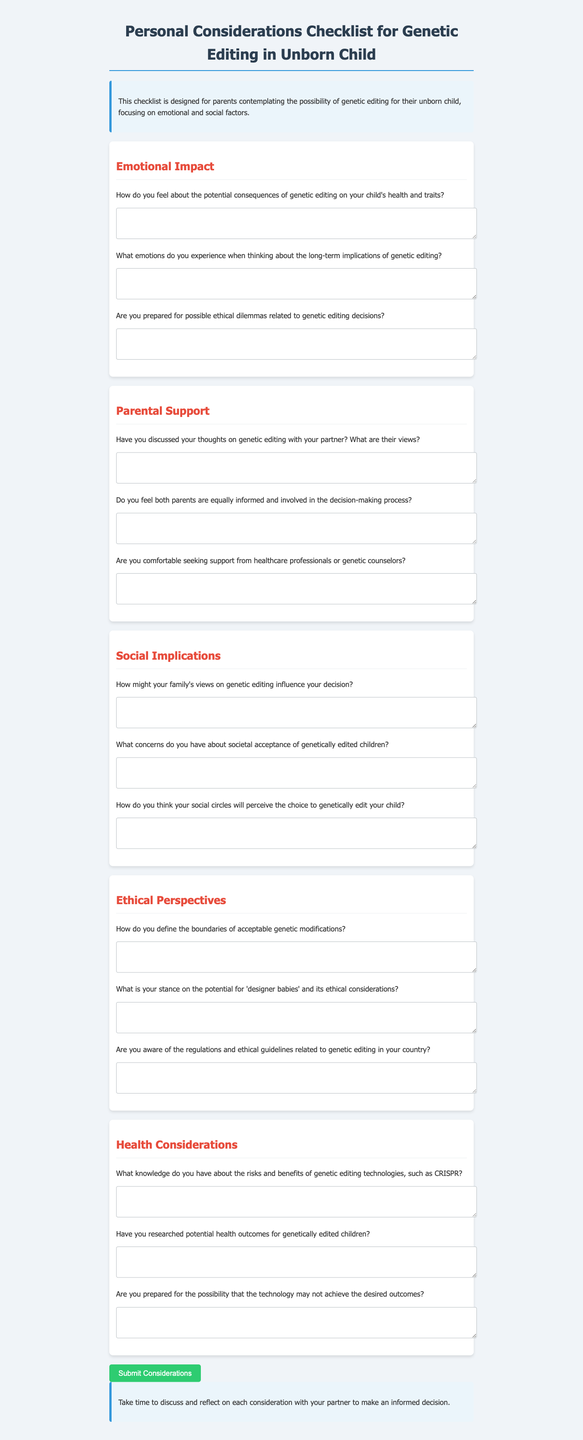What is the document about? The document is titled "Personal Considerations Checklist for Genetic Editing in Unborn Child" and focuses on emotional and social factors for parents contemplating genetic editing.
Answer: Genetic Editing Considerations How many categories are in the checklist? The checklist consists of five categories: Emotional Impact, Parental Support, Social Implications, Ethical Perspectives, and Health Considerations.
Answer: Five What question addresses parental support in discussions with partners? One of the questions under parental support is: "Have you discussed your thoughts on genetic editing with your partner? What are their views?"
Answer: Have you discussed your thoughts on genetic editing with your partner? What are their views? What is the last section in the document? The last section in the document is the conclusion, which encourages discussion and reflection among parents.
Answer: Conclusion What type of technology is mentioned in the health considerations section? The health considerations section mentions the genetic editing technology CRISPR.
Answer: CRISPR What should parents do after completing the form? The form includes a script that prompts parents to review their answers with their partner and healthcare professionals after submission.
Answer: Review your answers with your partner and healthcare professionals What are parents encouraged to consider before making a decision? Parents are encouraged to take time to discuss and reflect on each consideration with their partner.
Answer: Discuss and reflect on each consideration 